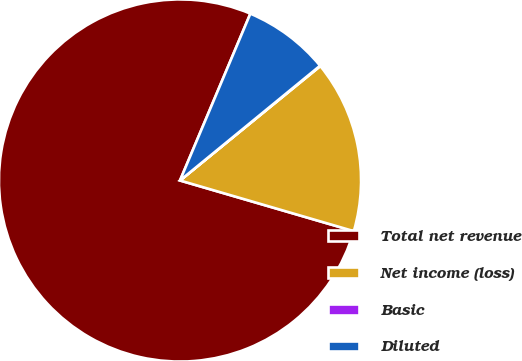Convert chart. <chart><loc_0><loc_0><loc_500><loc_500><pie_chart><fcel>Total net revenue<fcel>Net income (loss)<fcel>Basic<fcel>Diluted<nl><fcel>76.83%<fcel>15.4%<fcel>0.04%<fcel>7.72%<nl></chart> 